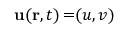<formula> <loc_0><loc_0><loc_500><loc_500>u ( r , t ) = ( u , v )</formula> 